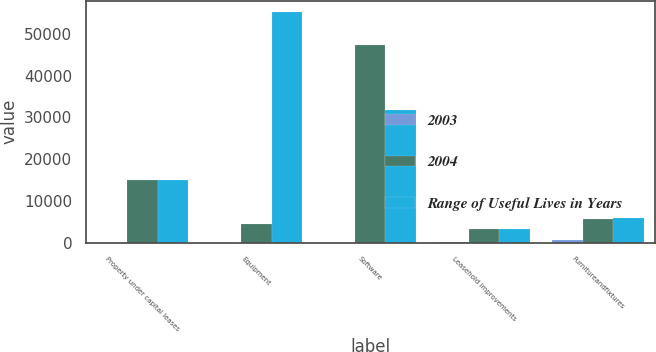Convert chart to OTSL. <chart><loc_0><loc_0><loc_500><loc_500><stacked_bar_chart><ecel><fcel>Property under capital leases<fcel>Equipment<fcel>Software<fcel>Leasehold improvements<fcel>Furnitureandfixtures<nl><fcel>2003<fcel>25<fcel>25<fcel>5<fcel>57<fcel>540<nl><fcel>2004<fcel>14989<fcel>4496.5<fcel>47381<fcel>3241<fcel>5690<nl><fcel>Range of Useful Lives in Years<fcel>14989<fcel>55180<fcel>31694<fcel>3303<fcel>5916<nl></chart> 